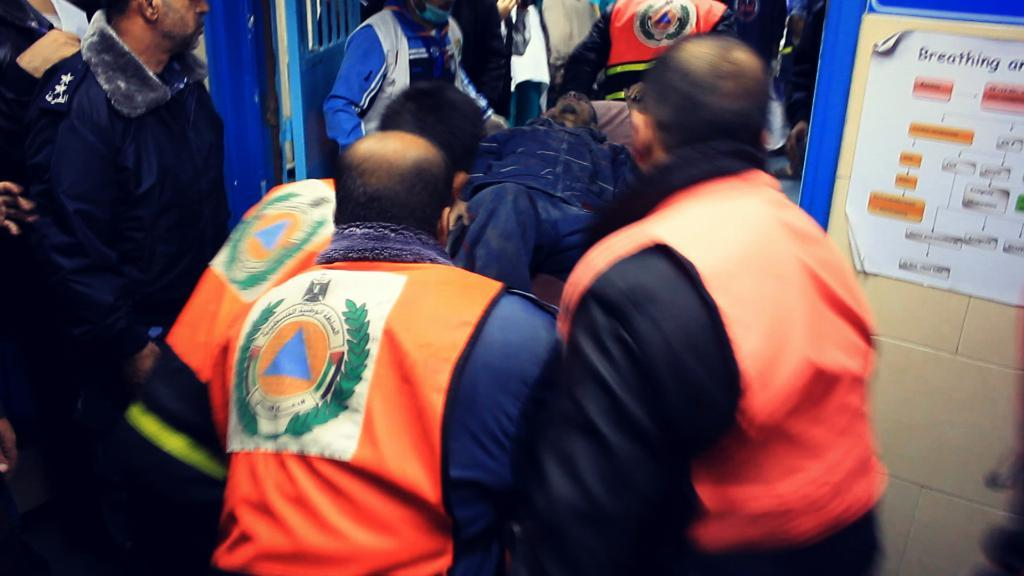How many individuals are present in the image? There are many people in the image. What are the people doing in the image? The people are carrying one man. What is the position of the man in the image? The man is lying down. Can you describe any additional objects or features in the image? There is a sticker on the right side of the image and a door visible at the top of the image. What type of cherry is being used as a prop in the image? There is no cherry present in the image. What school is visible in the background of the image? There is no school visible in the image. 